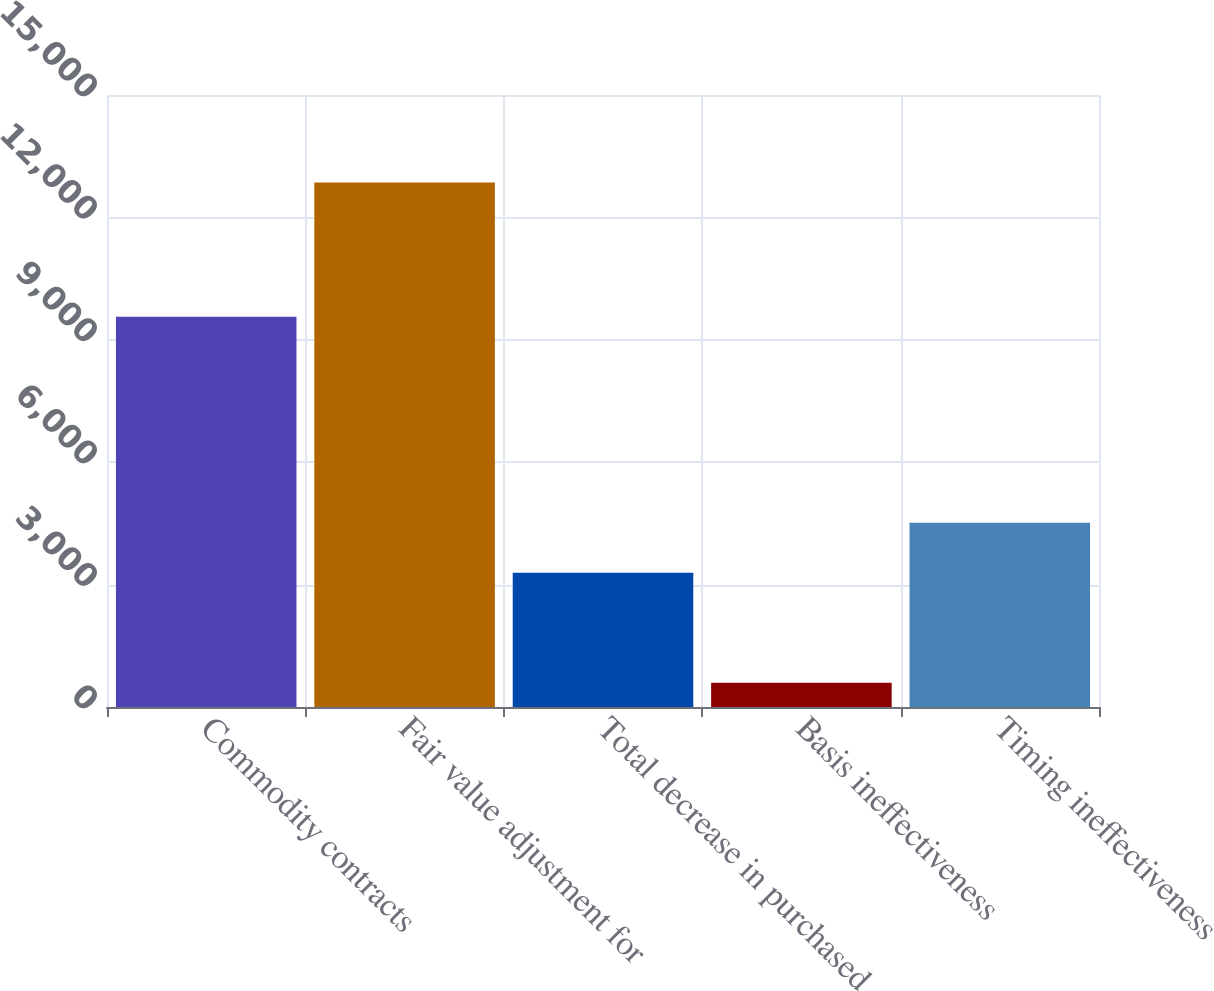Convert chart to OTSL. <chart><loc_0><loc_0><loc_500><loc_500><bar_chart><fcel>Commodity contracts<fcel>Fair value adjustment for<fcel>Total decrease in purchased<fcel>Basis ineffectiveness<fcel>Timing ineffectiveness<nl><fcel>9567<fcel>12858<fcel>3291<fcel>597<fcel>4517.1<nl></chart> 